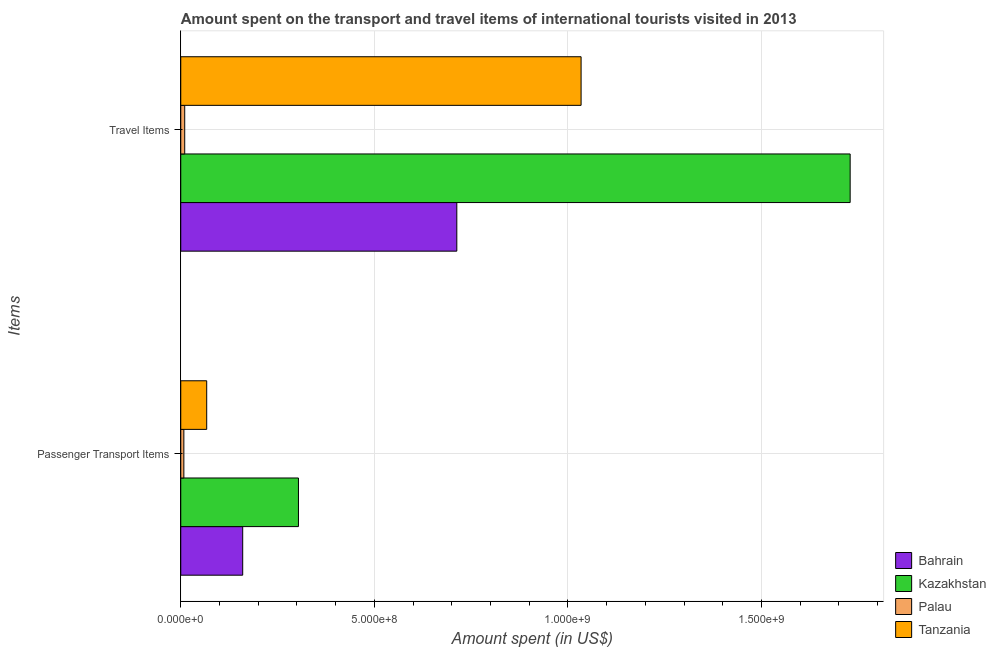Are the number of bars per tick equal to the number of legend labels?
Offer a terse response. Yes. How many bars are there on the 1st tick from the top?
Keep it short and to the point. 4. How many bars are there on the 1st tick from the bottom?
Ensure brevity in your answer.  4. What is the label of the 1st group of bars from the top?
Your response must be concise. Travel Items. What is the amount spent in travel items in Palau?
Offer a very short reply. 1.02e+07. Across all countries, what is the maximum amount spent on passenger transport items?
Provide a short and direct response. 3.04e+08. Across all countries, what is the minimum amount spent in travel items?
Your response must be concise. 1.02e+07. In which country was the amount spent in travel items maximum?
Your answer should be very brief. Kazakhstan. In which country was the amount spent in travel items minimum?
Keep it short and to the point. Palau. What is the total amount spent on passenger transport items in the graph?
Your answer should be very brief. 5.39e+08. What is the difference between the amount spent on passenger transport items in Palau and that in Kazakhstan?
Offer a very short reply. -2.96e+08. What is the difference between the amount spent in travel items in Tanzania and the amount spent on passenger transport items in Kazakhstan?
Provide a succinct answer. 7.30e+08. What is the average amount spent in travel items per country?
Offer a very short reply. 8.72e+08. What is the difference between the amount spent on passenger transport items and amount spent in travel items in Palau?
Offer a very short reply. -2.20e+06. In how many countries, is the amount spent in travel items greater than 800000000 US$?
Keep it short and to the point. 2. What is the ratio of the amount spent in travel items in Palau to that in Kazakhstan?
Give a very brief answer. 0.01. Is the amount spent in travel items in Kazakhstan less than that in Bahrain?
Give a very brief answer. No. What does the 2nd bar from the top in Travel Items represents?
Make the answer very short. Palau. What does the 2nd bar from the bottom in Travel Items represents?
Provide a succinct answer. Kazakhstan. Are all the bars in the graph horizontal?
Offer a terse response. Yes. What is the difference between two consecutive major ticks on the X-axis?
Make the answer very short. 5.00e+08. Are the values on the major ticks of X-axis written in scientific E-notation?
Offer a very short reply. Yes. Does the graph contain any zero values?
Your answer should be compact. No. Does the graph contain grids?
Offer a terse response. Yes. How many legend labels are there?
Provide a short and direct response. 4. What is the title of the graph?
Your answer should be very brief. Amount spent on the transport and travel items of international tourists visited in 2013. Does "Mexico" appear as one of the legend labels in the graph?
Make the answer very short. No. What is the label or title of the X-axis?
Offer a terse response. Amount spent (in US$). What is the label or title of the Y-axis?
Provide a succinct answer. Items. What is the Amount spent (in US$) of Bahrain in Passenger Transport Items?
Provide a short and direct response. 1.60e+08. What is the Amount spent (in US$) in Kazakhstan in Passenger Transport Items?
Make the answer very short. 3.04e+08. What is the Amount spent (in US$) of Palau in Passenger Transport Items?
Offer a terse response. 8.00e+06. What is the Amount spent (in US$) of Tanzania in Passenger Transport Items?
Your answer should be very brief. 6.70e+07. What is the Amount spent (in US$) of Bahrain in Travel Items?
Your response must be concise. 7.13e+08. What is the Amount spent (in US$) in Kazakhstan in Travel Items?
Provide a short and direct response. 1.73e+09. What is the Amount spent (in US$) of Palau in Travel Items?
Make the answer very short. 1.02e+07. What is the Amount spent (in US$) of Tanzania in Travel Items?
Give a very brief answer. 1.03e+09. Across all Items, what is the maximum Amount spent (in US$) in Bahrain?
Make the answer very short. 7.13e+08. Across all Items, what is the maximum Amount spent (in US$) in Kazakhstan?
Offer a terse response. 1.73e+09. Across all Items, what is the maximum Amount spent (in US$) in Palau?
Provide a succinct answer. 1.02e+07. Across all Items, what is the maximum Amount spent (in US$) of Tanzania?
Provide a short and direct response. 1.03e+09. Across all Items, what is the minimum Amount spent (in US$) in Bahrain?
Your answer should be very brief. 1.60e+08. Across all Items, what is the minimum Amount spent (in US$) in Kazakhstan?
Offer a very short reply. 3.04e+08. Across all Items, what is the minimum Amount spent (in US$) of Tanzania?
Offer a very short reply. 6.70e+07. What is the total Amount spent (in US$) of Bahrain in the graph?
Give a very brief answer. 8.73e+08. What is the total Amount spent (in US$) in Kazakhstan in the graph?
Ensure brevity in your answer.  2.03e+09. What is the total Amount spent (in US$) in Palau in the graph?
Provide a succinct answer. 1.82e+07. What is the total Amount spent (in US$) of Tanzania in the graph?
Your answer should be compact. 1.10e+09. What is the difference between the Amount spent (in US$) in Bahrain in Passenger Transport Items and that in Travel Items?
Your answer should be compact. -5.53e+08. What is the difference between the Amount spent (in US$) in Kazakhstan in Passenger Transport Items and that in Travel Items?
Ensure brevity in your answer.  -1.42e+09. What is the difference between the Amount spent (in US$) of Palau in Passenger Transport Items and that in Travel Items?
Give a very brief answer. -2.20e+06. What is the difference between the Amount spent (in US$) in Tanzania in Passenger Transport Items and that in Travel Items?
Give a very brief answer. -9.67e+08. What is the difference between the Amount spent (in US$) of Bahrain in Passenger Transport Items and the Amount spent (in US$) of Kazakhstan in Travel Items?
Your answer should be very brief. -1.57e+09. What is the difference between the Amount spent (in US$) in Bahrain in Passenger Transport Items and the Amount spent (in US$) in Palau in Travel Items?
Your answer should be compact. 1.50e+08. What is the difference between the Amount spent (in US$) in Bahrain in Passenger Transport Items and the Amount spent (in US$) in Tanzania in Travel Items?
Offer a very short reply. -8.74e+08. What is the difference between the Amount spent (in US$) in Kazakhstan in Passenger Transport Items and the Amount spent (in US$) in Palau in Travel Items?
Keep it short and to the point. 2.94e+08. What is the difference between the Amount spent (in US$) of Kazakhstan in Passenger Transport Items and the Amount spent (in US$) of Tanzania in Travel Items?
Your answer should be compact. -7.30e+08. What is the difference between the Amount spent (in US$) in Palau in Passenger Transport Items and the Amount spent (in US$) in Tanzania in Travel Items?
Provide a short and direct response. -1.03e+09. What is the average Amount spent (in US$) of Bahrain per Items?
Provide a succinct answer. 4.36e+08. What is the average Amount spent (in US$) of Kazakhstan per Items?
Give a very brief answer. 1.02e+09. What is the average Amount spent (in US$) of Palau per Items?
Keep it short and to the point. 9.10e+06. What is the average Amount spent (in US$) in Tanzania per Items?
Provide a short and direct response. 5.50e+08. What is the difference between the Amount spent (in US$) in Bahrain and Amount spent (in US$) in Kazakhstan in Passenger Transport Items?
Your response must be concise. -1.44e+08. What is the difference between the Amount spent (in US$) in Bahrain and Amount spent (in US$) in Palau in Passenger Transport Items?
Your response must be concise. 1.52e+08. What is the difference between the Amount spent (in US$) in Bahrain and Amount spent (in US$) in Tanzania in Passenger Transport Items?
Give a very brief answer. 9.30e+07. What is the difference between the Amount spent (in US$) in Kazakhstan and Amount spent (in US$) in Palau in Passenger Transport Items?
Offer a terse response. 2.96e+08. What is the difference between the Amount spent (in US$) of Kazakhstan and Amount spent (in US$) of Tanzania in Passenger Transport Items?
Provide a short and direct response. 2.37e+08. What is the difference between the Amount spent (in US$) of Palau and Amount spent (in US$) of Tanzania in Passenger Transport Items?
Your answer should be compact. -5.90e+07. What is the difference between the Amount spent (in US$) of Bahrain and Amount spent (in US$) of Kazakhstan in Travel Items?
Offer a very short reply. -1.02e+09. What is the difference between the Amount spent (in US$) of Bahrain and Amount spent (in US$) of Palau in Travel Items?
Offer a terse response. 7.03e+08. What is the difference between the Amount spent (in US$) of Bahrain and Amount spent (in US$) of Tanzania in Travel Items?
Make the answer very short. -3.21e+08. What is the difference between the Amount spent (in US$) in Kazakhstan and Amount spent (in US$) in Palau in Travel Items?
Make the answer very short. 1.72e+09. What is the difference between the Amount spent (in US$) in Kazakhstan and Amount spent (in US$) in Tanzania in Travel Items?
Provide a succinct answer. 6.95e+08. What is the difference between the Amount spent (in US$) in Palau and Amount spent (in US$) in Tanzania in Travel Items?
Make the answer very short. -1.02e+09. What is the ratio of the Amount spent (in US$) in Bahrain in Passenger Transport Items to that in Travel Items?
Offer a very short reply. 0.22. What is the ratio of the Amount spent (in US$) in Kazakhstan in Passenger Transport Items to that in Travel Items?
Your answer should be very brief. 0.18. What is the ratio of the Amount spent (in US$) in Palau in Passenger Transport Items to that in Travel Items?
Offer a very short reply. 0.78. What is the ratio of the Amount spent (in US$) in Tanzania in Passenger Transport Items to that in Travel Items?
Provide a short and direct response. 0.06. What is the difference between the highest and the second highest Amount spent (in US$) in Bahrain?
Keep it short and to the point. 5.53e+08. What is the difference between the highest and the second highest Amount spent (in US$) of Kazakhstan?
Provide a succinct answer. 1.42e+09. What is the difference between the highest and the second highest Amount spent (in US$) of Palau?
Your answer should be compact. 2.20e+06. What is the difference between the highest and the second highest Amount spent (in US$) of Tanzania?
Your answer should be very brief. 9.67e+08. What is the difference between the highest and the lowest Amount spent (in US$) of Bahrain?
Keep it short and to the point. 5.53e+08. What is the difference between the highest and the lowest Amount spent (in US$) of Kazakhstan?
Provide a short and direct response. 1.42e+09. What is the difference between the highest and the lowest Amount spent (in US$) of Palau?
Ensure brevity in your answer.  2.20e+06. What is the difference between the highest and the lowest Amount spent (in US$) of Tanzania?
Make the answer very short. 9.67e+08. 